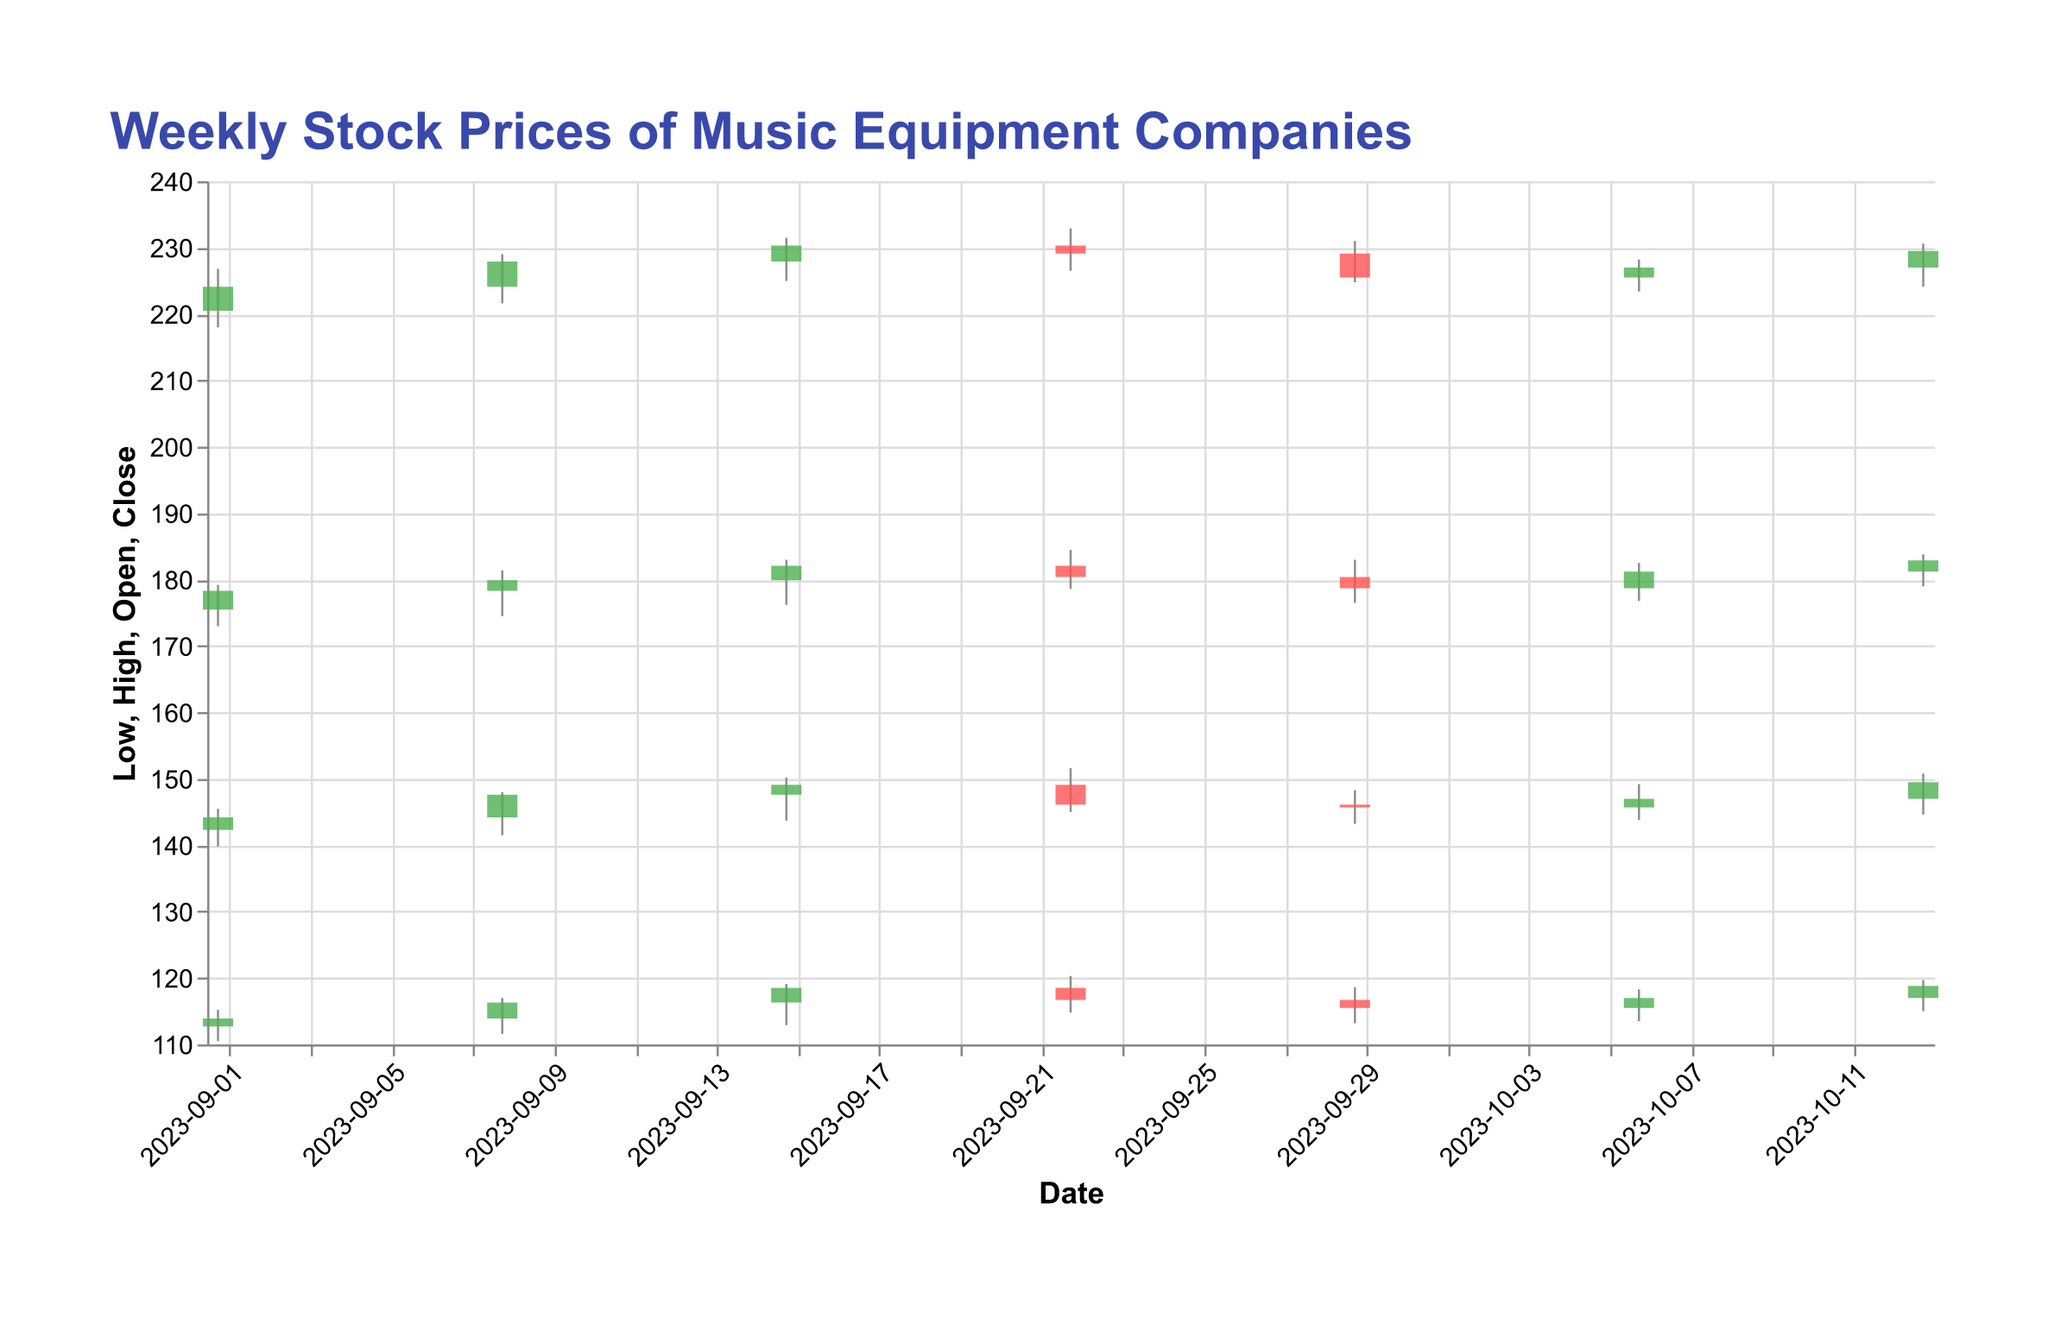What is the title of the figure? The title is displayed at the top of the chart. It reads "Weekly Stock Prices of Music Equipment Companies".
Answer: Weekly Stock Prices of Music Equipment Companies How many weeks of trading data are shown in the figure? Each set of candlesticks represents a week of trading data and there are 7 such sets in the figure.
Answer: 7 What does a green bar indicate? A green bar indicates that the closing price was higher than the opening price for that week. This is seen by the green color in the candlestick.
Answer: Closing price higher than opening price Which week had the highest trading volume? By looking at the volume data, the highest trading volume is seen for the week ending on 2023-09-08 with a volume of 6,300,000 shares.
Answer: 2023-09-08 How did the stock price for the week ending 2023-09-29 compare to the previous week? For the week ending on 2023-09-29, the stock closed lower (225.50) compared to the previous week's closing price (229.10), indicating a decrease.
Answer: Lower What is the difference between the highest and lowest prices for the week ending 2023-10-06? For the week ending on 2023-10-06, the highest price is 228.20 and the lowest price is 223.40, so the difference is 228.20 - 223.40 = 4.80.
Answer: 4.80 Which week had the smallest range between high and low prices? To determine this, we must calculate the range for each week (High - Low) and compare. The smallest range appears for the week ending 2023-09-01, where the difference was 226.80 - 218.00 = 8.80.
Answer: 2023-09-01 During which week did the stock's opening price equal its closing price? By examining the data, there were no weeks where the opening price and closing price were equal.
Answer: None What is the average closing price of the stocks shown across all weeks? Sum the closing prices for all weeks and divide by the number of weeks: (224.10 + 227.90 + 230.30 + 229.10 + 225.50 + 227.00 + 229.50) / 7 = 227.20.
Answer: 227.20 How does the closing price on 2023-10-13 compare to the closing price on 2023-09-15? The closing price on 2023-10-13 (229.50) is lower than the closing price on 2023-09-15 (230.30).
Answer: Lower 